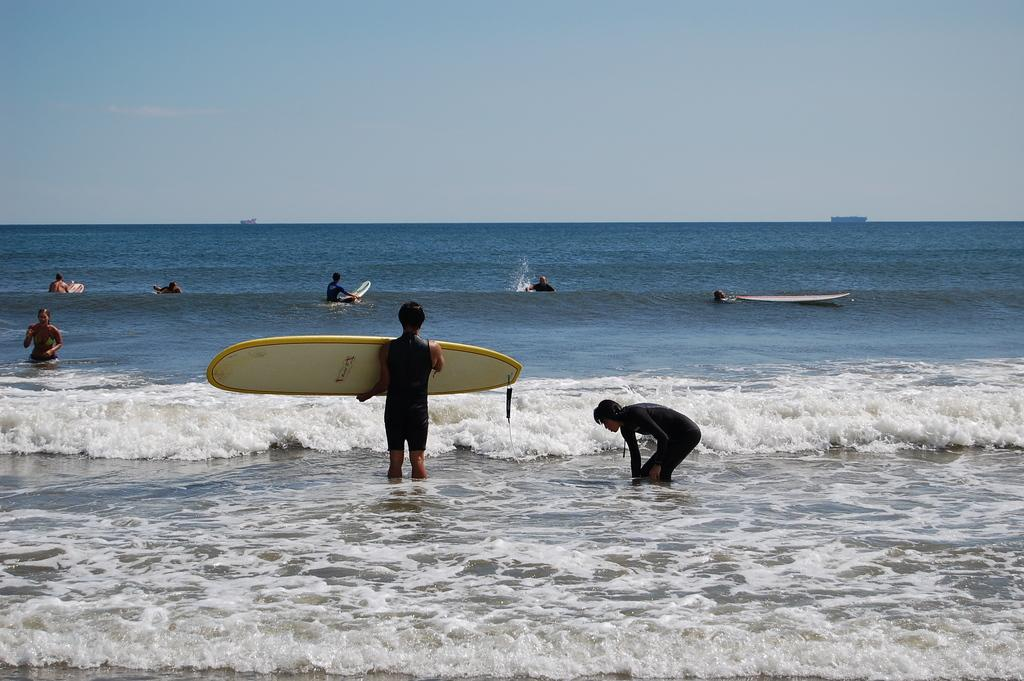What is the main setting of the image? The image depicts an ocean. Are there any people present in the image? Yes, there are people standing near the ocean. What is the man holding in his hand? The man is holding a surf boat in his hand. Are there any people on the surf boat? Yes, some people are on the surf boat. What is the color of the sky in the image? The sky is blue in the image. Can you see any chess pieces on the beach in the image? There are no chess pieces visible in the image. Are there any insects crawling on the surf boat in the image? There is no indication of insects on the surf boat in the image. 